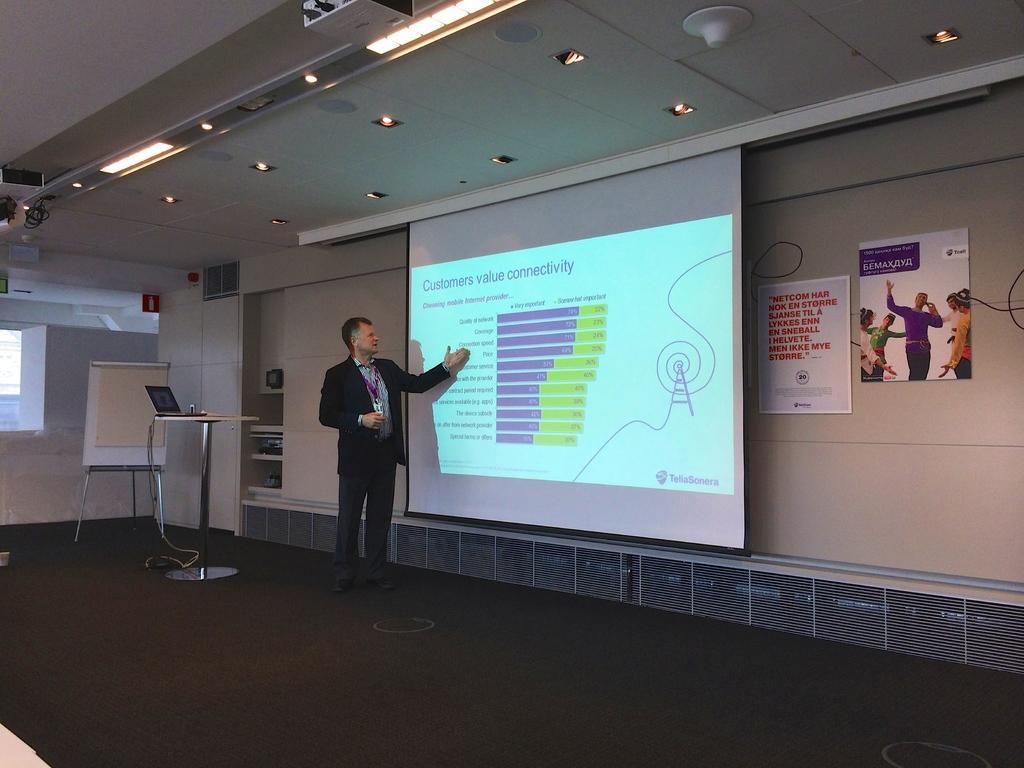Please provide a concise description of this image. In the foreground of this picture, there is a man talking by looking to a screen. In this image there are table, laptop, board, wall, ceiling, lights, posters, and the floor. 